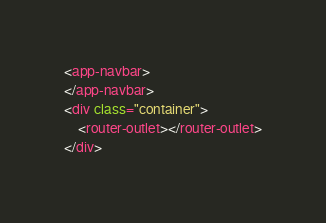Convert code to text. <code><loc_0><loc_0><loc_500><loc_500><_HTML_><app-navbar>
</app-navbar>
<div class="container">
	<router-outlet></router-outlet>
</div></code> 